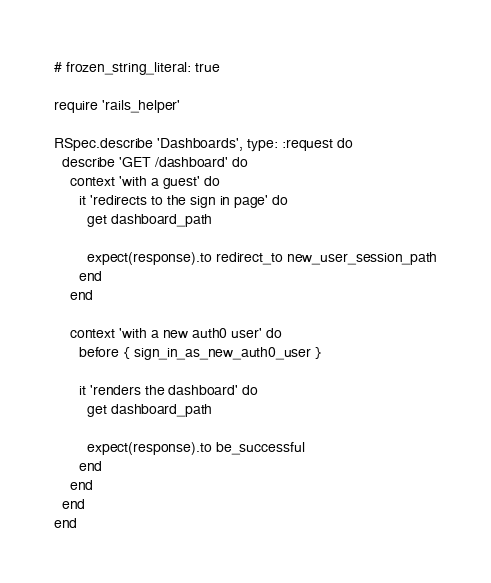Convert code to text. <code><loc_0><loc_0><loc_500><loc_500><_Ruby_># frozen_string_literal: true

require 'rails_helper'

RSpec.describe 'Dashboards', type: :request do
  describe 'GET /dashboard' do
    context 'with a guest' do
      it 'redirects to the sign in page' do
        get dashboard_path

        expect(response).to redirect_to new_user_session_path
      end
    end

    context 'with a new auth0 user' do
      before { sign_in_as_new_auth0_user }

      it 'renders the dashboard' do
        get dashboard_path

        expect(response).to be_successful
      end
    end
  end
end
</code> 